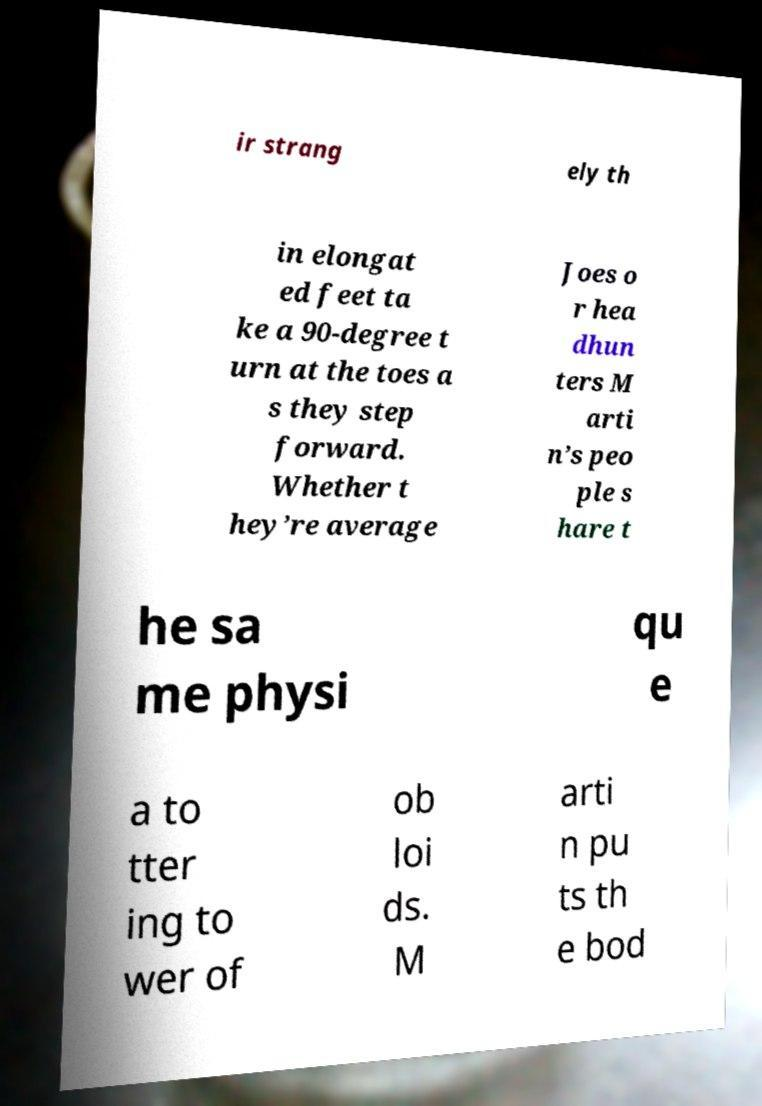Could you extract and type out the text from this image? ir strang ely th in elongat ed feet ta ke a 90-degree t urn at the toes a s they step forward. Whether t hey’re average Joes o r hea dhun ters M arti n’s peo ple s hare t he sa me physi qu e a to tter ing to wer of ob loi ds. M arti n pu ts th e bod 